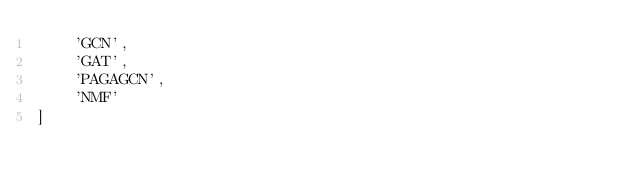<code> <loc_0><loc_0><loc_500><loc_500><_Python_>    'GCN',
    'GAT',
    'PAGAGCN',
    'NMF'
]
</code> 